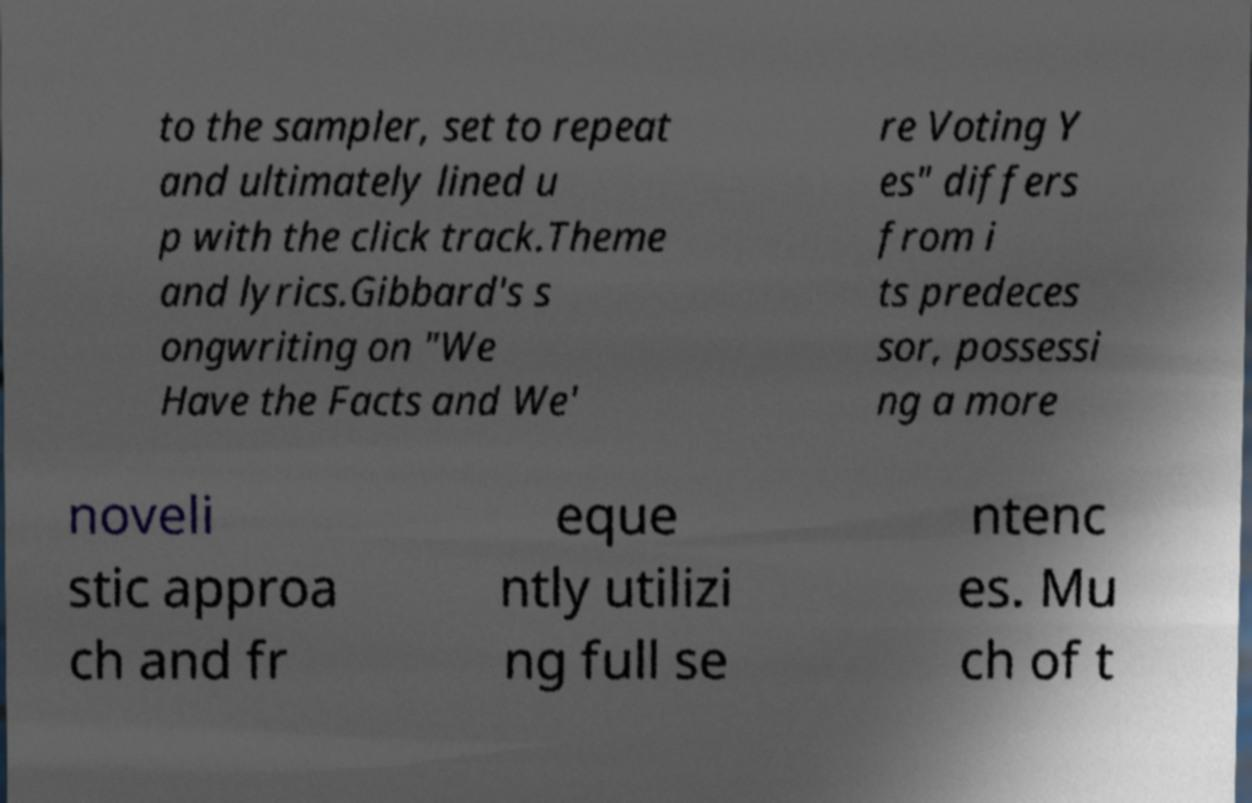I need the written content from this picture converted into text. Can you do that? to the sampler, set to repeat and ultimately lined u p with the click track.Theme and lyrics.Gibbard's s ongwriting on "We Have the Facts and We' re Voting Y es" differs from i ts predeces sor, possessi ng a more noveli stic approa ch and fr eque ntly utilizi ng full se ntenc es. Mu ch of t 